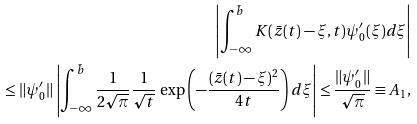<formula> <loc_0><loc_0><loc_500><loc_500>\left | \int _ { - \infty } ^ { \bar { b } } K ( \bar { z } ( t ) - \xi , t ) \psi ^ { \prime } _ { 0 } ( \xi ) d \xi \right | \\ \leq \| \psi ^ { \prime } _ { 0 } \| \left | \int _ { - \infty } ^ { \bar { b } } \frac { 1 } { 2 \sqrt { \pi } } \frac { 1 } { \sqrt { t } } \, \exp \left ( - \frac { ( \bar { z } ( t ) - \xi ) ^ { 2 } } { 4 t } \right ) d \xi \right | \leq \frac { \| \psi ^ { \prime } _ { 0 } \| } { \sqrt { \pi } } \equiv A _ { 1 } ,</formula> 